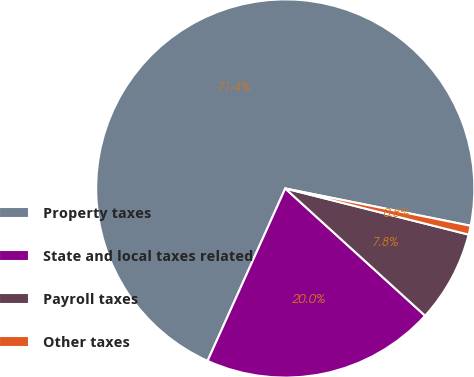<chart> <loc_0><loc_0><loc_500><loc_500><pie_chart><fcel>Property taxes<fcel>State and local taxes related<fcel>Payroll taxes<fcel>Other taxes<nl><fcel>71.42%<fcel>19.99%<fcel>7.83%<fcel>0.76%<nl></chart> 